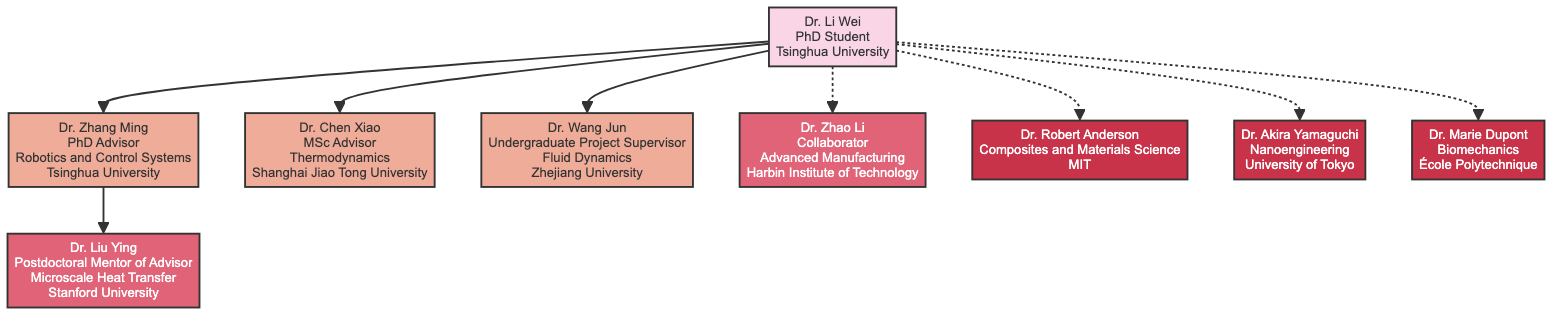What is the name of the PhD student? The diagram starts with the node labeled "Dr. Li Wei," who is identified as the PhD student.
Answer: Dr. Li Wei Who is Dr. Li Wei's PhD advisor? The diagram shows a direct connection from Dr. Li Wei to Dr. Zhang Ming, indicating that he is the PhD advisor.
Answer: Dr. Zhang Ming Which institution did Dr. Chen Xiao belong to? The diagram indicates that Dr. Chen Xiao is connected to Dr. Li Wei as an MSc advisor, and it specifies that his institution is "Shanghai Jiao Tong University."
Answer: Shanghai Jiao Tong University How many academic advisors does Dr. Li Wei have? There are three direct connections labeled PhD advisor, MSc advisor, and Undergraduate Project Supervisor, indicating that Dr. Li Wei has three academic advisors.
Answer: 3 Who is the postdoctoral mentor of Dr. Zhang Ming? The diagram illustrates that Dr. Zhang Ming is linked to Dr. Liu Ying, who is identified as the postdoctoral mentor.
Answer: Dr. Liu Ying What is the specialization of Dr. Zhao Li? The diagram states that Dr. Zhao Li, who is labeled as a collaborator, specializes in "Advanced Manufacturing."
Answer: Advanced Manufacturing List the specialization of Dr. Robert Anderson. The diagram highlights Dr. Robert Anderson and specifies his specialization as "Composites and Materials Science."
Answer: Composites and Materials Science Which advisor has a connection to Dr. Wei through fluid dynamics? The diagram reflects that Dr. Wang Jun is connected to Dr. Li Wei through the relationship of Undergraduate Project Supervisor, specializing in fluid dynamics.
Answer: Dr. Wang Jun How many collaborators are indicated in the diagram? The diagram shows one dashed line leading to Dr. Zhao Li, indicating that there is one collaborator for Dr. Li Wei.
Answer: 1 